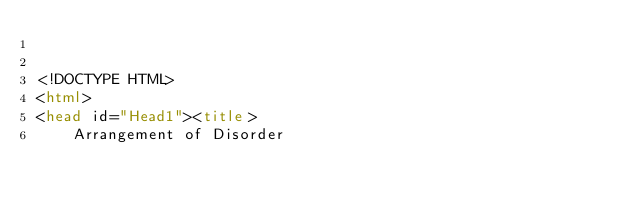<code> <loc_0><loc_0><loc_500><loc_500><_HTML_>

<!DOCTYPE HTML>
<html>
<head id="Head1"><title>
	Arrangement of Disorder</code> 